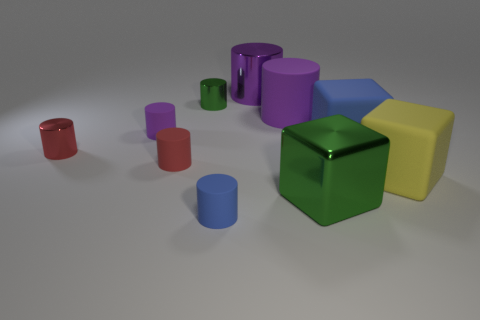How many purple cylinders must be subtracted to get 1 purple cylinders? 2 Subtract all brown balls. How many purple cylinders are left? 3 Subtract all green cylinders. How many cylinders are left? 6 Subtract all tiny green cylinders. How many cylinders are left? 6 Subtract all blue cylinders. Subtract all red cubes. How many cylinders are left? 6 Subtract all blocks. How many objects are left? 7 Subtract 1 purple cylinders. How many objects are left? 9 Subtract all big purple rubber objects. Subtract all yellow rubber cubes. How many objects are left? 8 Add 3 small blue cylinders. How many small blue cylinders are left? 4 Add 8 blue cylinders. How many blue cylinders exist? 9 